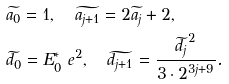Convert formula to latex. <formula><loc_0><loc_0><loc_500><loc_500>& \widetilde { a _ { 0 } } = 1 , \quad \widetilde { a _ { j + 1 } } = 2 \widetilde { a _ { j } } + 2 , \\ & \widetilde { d _ { 0 } } = E _ { 0 } ^ { * } \ e ^ { 2 } , \quad \widetilde { d _ { j + 1 } } = \frac { \widetilde { d _ { j } } ^ { 2 } } { 3 \cdot 2 ^ { 3 j + 9 } } .</formula> 